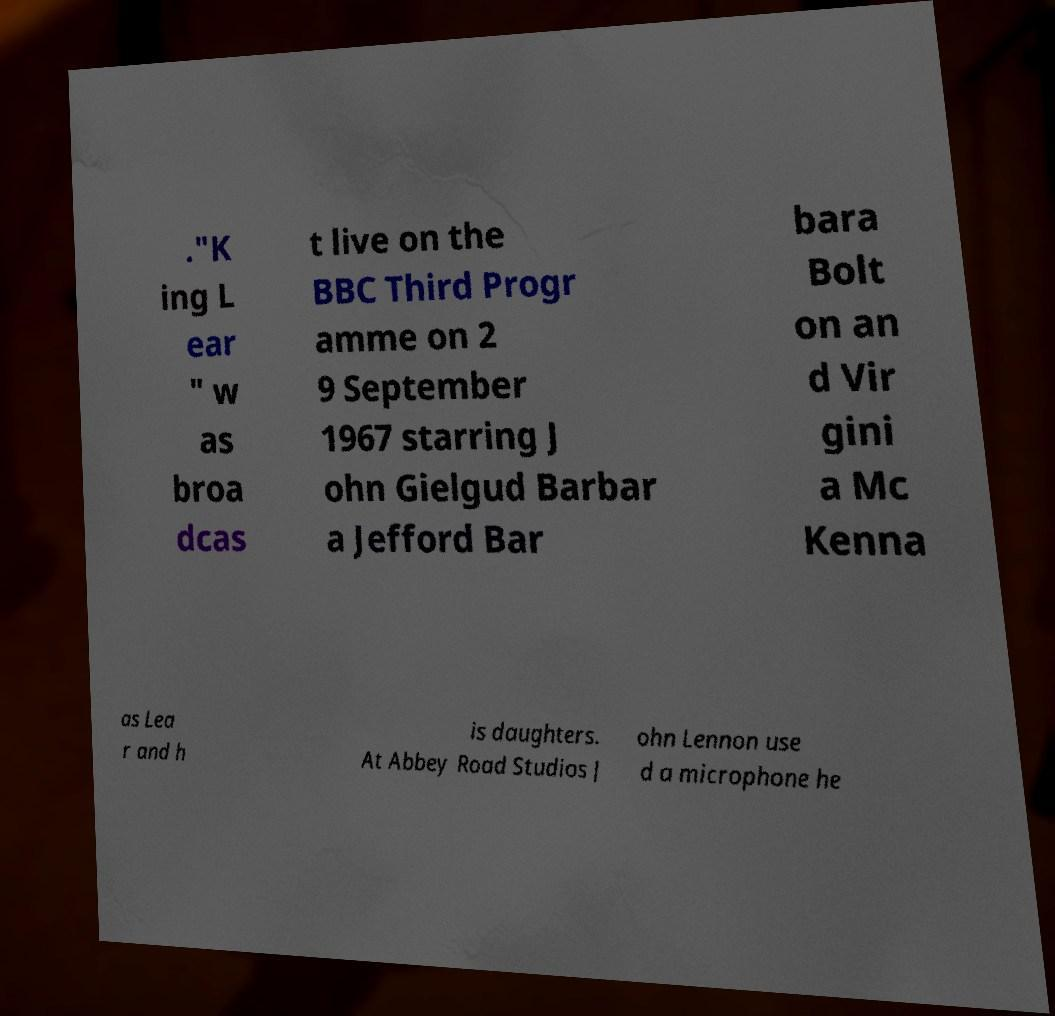For documentation purposes, I need the text within this image transcribed. Could you provide that? ."K ing L ear " w as broa dcas t live on the BBC Third Progr amme on 2 9 September 1967 starring J ohn Gielgud Barbar a Jefford Bar bara Bolt on an d Vir gini a Mc Kenna as Lea r and h is daughters. At Abbey Road Studios J ohn Lennon use d a microphone he 